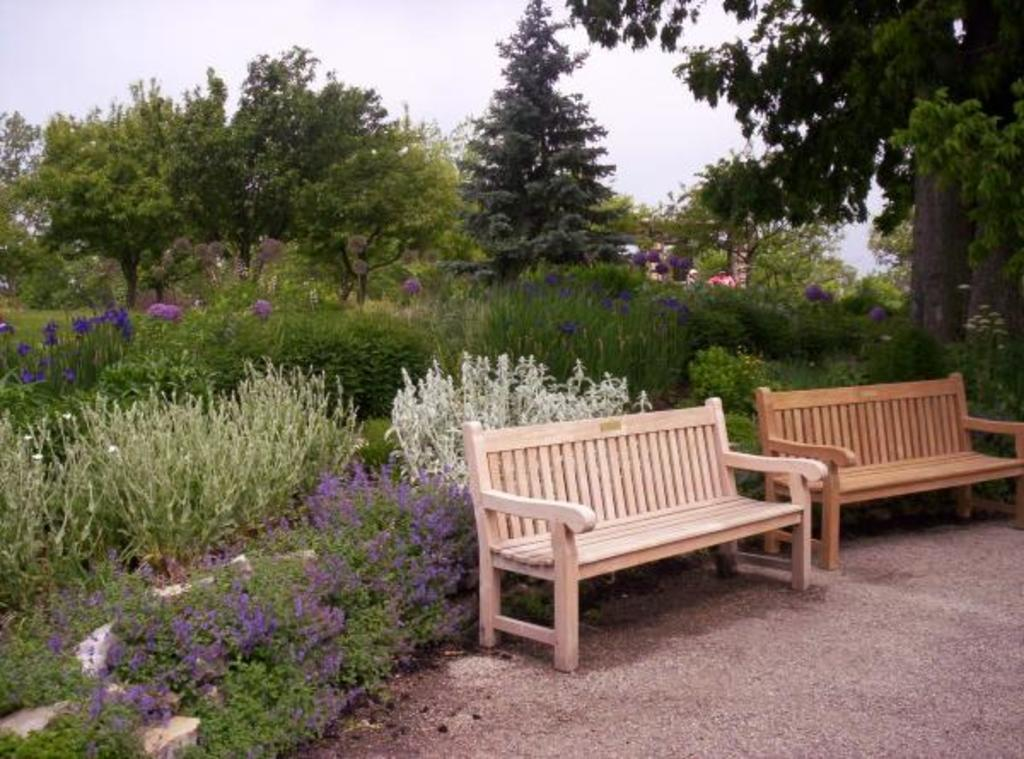How many benches are in the image? There are two benches in the image. What type of plants can be seen in the image? There are flowering plants in the image. What other natural elements are present in the image? There are trees in the image. Can you describe the person in the image? There is a person in the image, but no specific details about the person are provided. What is visible in the background of the image? The sky is visible in the image. Based on the presence of trees, plants, and benches, where might this image have been taken? The image may have been taken in a park. What type of crate is being pushed by the person in the image? There is no crate or person pushing a crate present in the image. What type of spade is being used by the person in the image? There is no person or spade present in the image. 